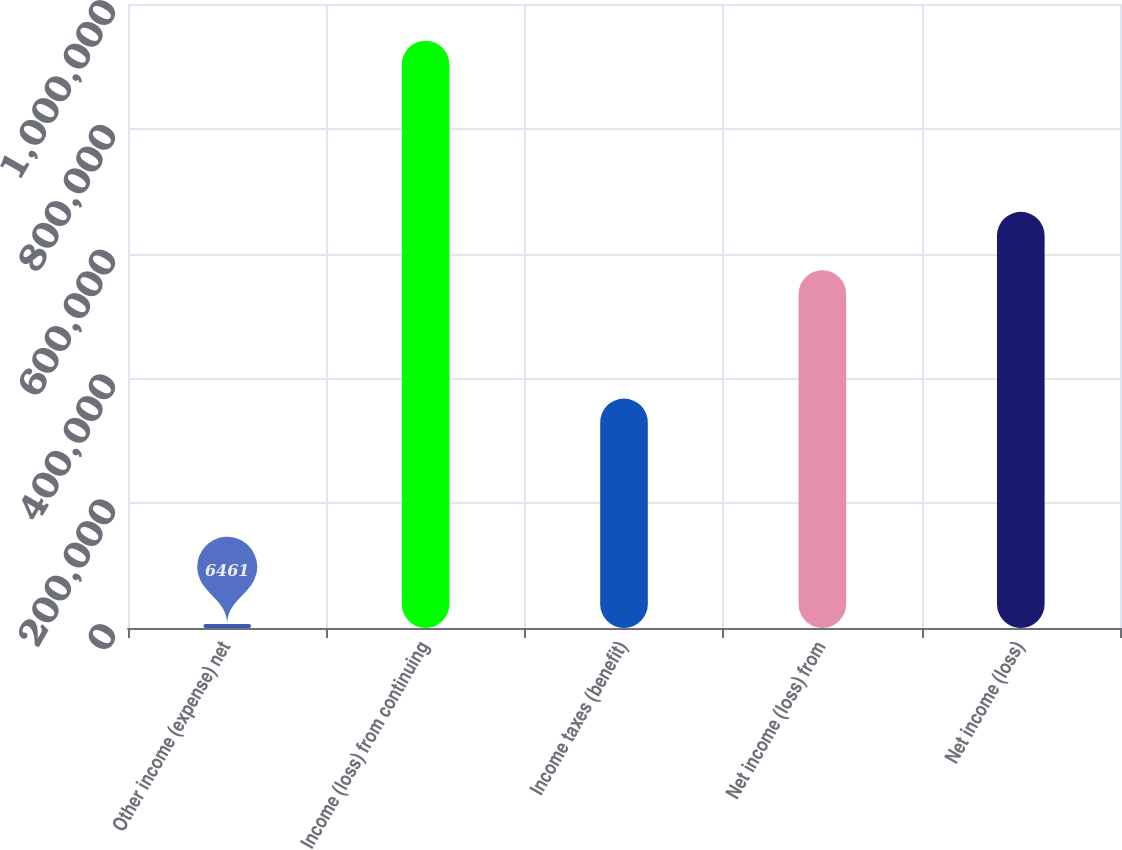Convert chart to OTSL. <chart><loc_0><loc_0><loc_500><loc_500><bar_chart><fcel>Other income (expense) net<fcel>Income (loss) from continuing<fcel>Income taxes (benefit)<fcel>Net income (loss) from<fcel>Net income (loss)<nl><fcel>6461<fcel>941090<fcel>367660<fcel>573430<fcel>666893<nl></chart> 